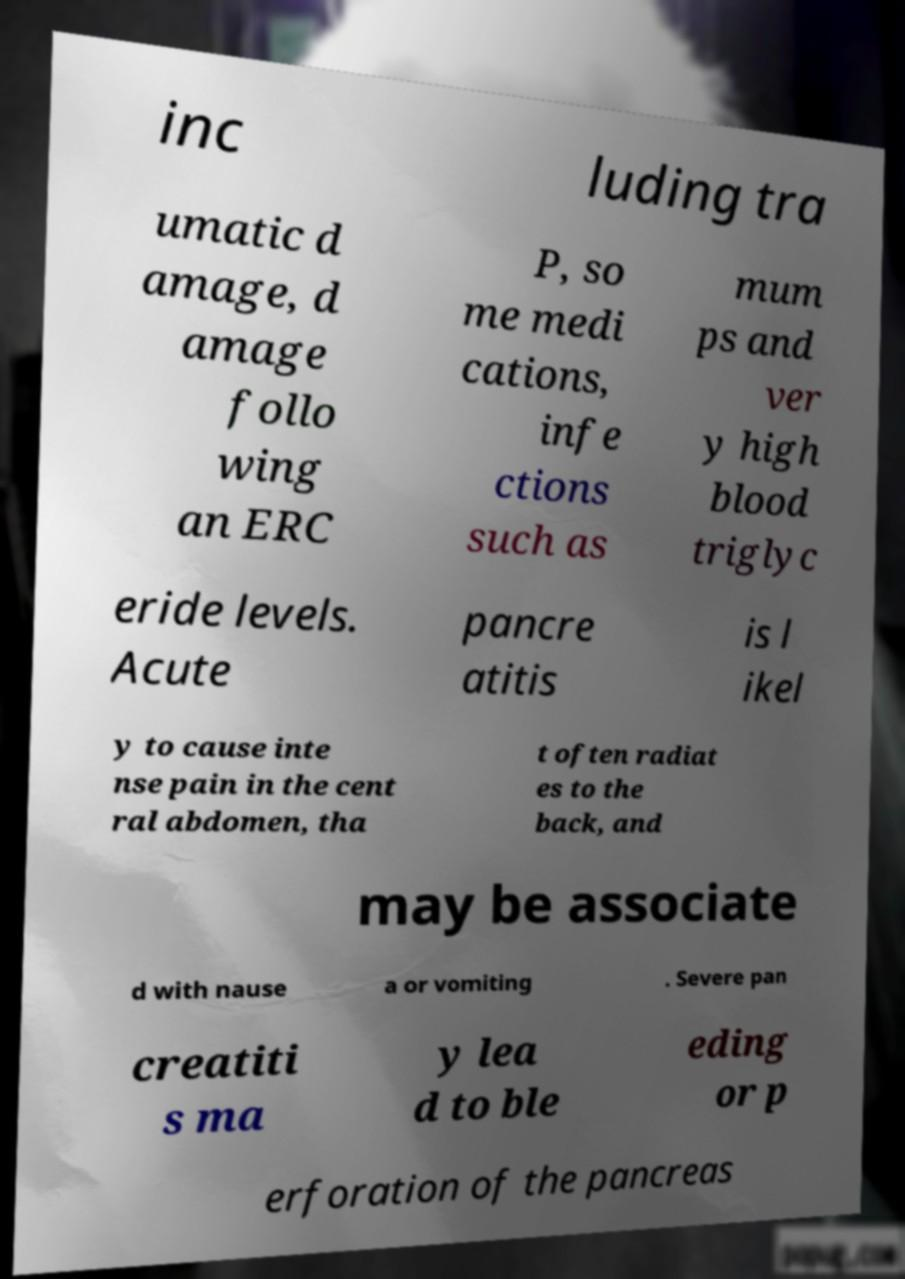Please identify and transcribe the text found in this image. inc luding tra umatic d amage, d amage follo wing an ERC P, so me medi cations, infe ctions such as mum ps and ver y high blood triglyc eride levels. Acute pancre atitis is l ikel y to cause inte nse pain in the cent ral abdomen, tha t often radiat es to the back, and may be associate d with nause a or vomiting . Severe pan creatiti s ma y lea d to ble eding or p erforation of the pancreas 